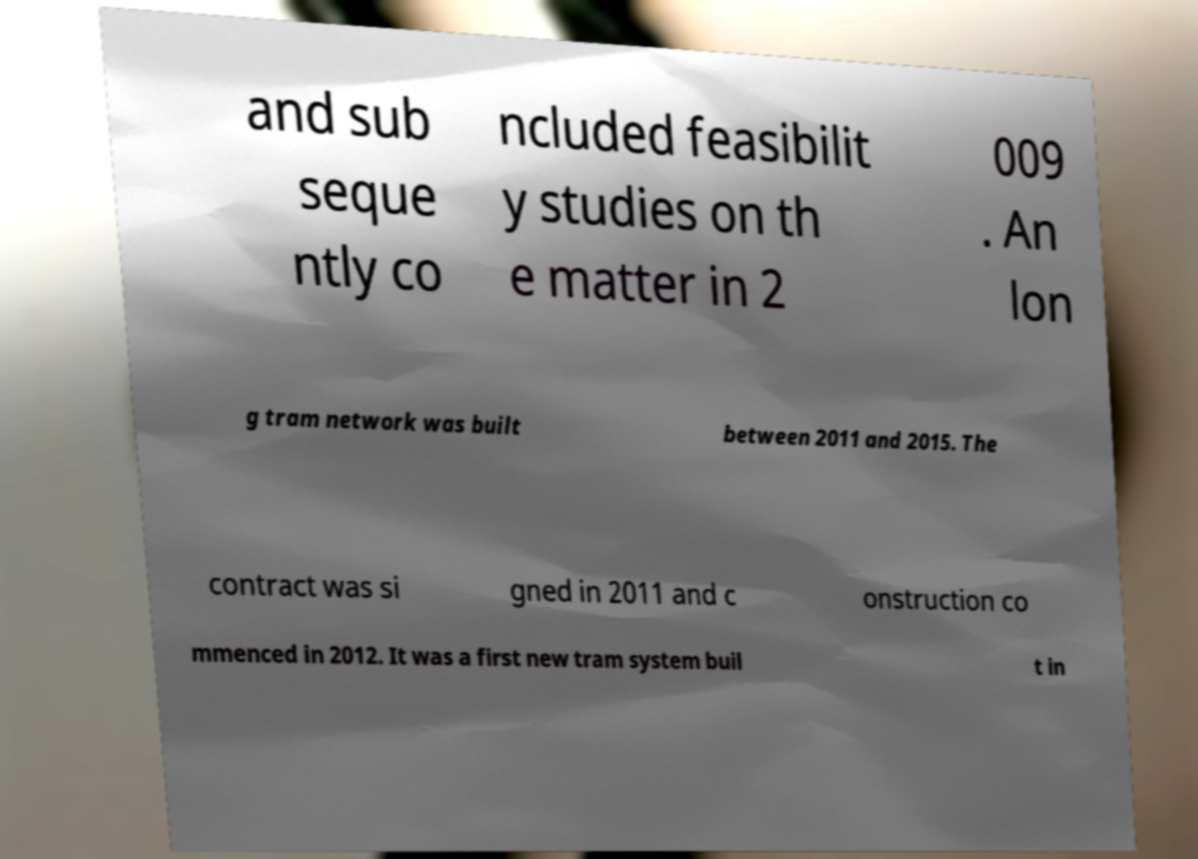Can you read and provide the text displayed in the image?This photo seems to have some interesting text. Can you extract and type it out for me? and sub seque ntly co ncluded feasibilit y studies on th e matter in 2 009 . An lon g tram network was built between 2011 and 2015. The contract was si gned in 2011 and c onstruction co mmenced in 2012. It was a first new tram system buil t in 